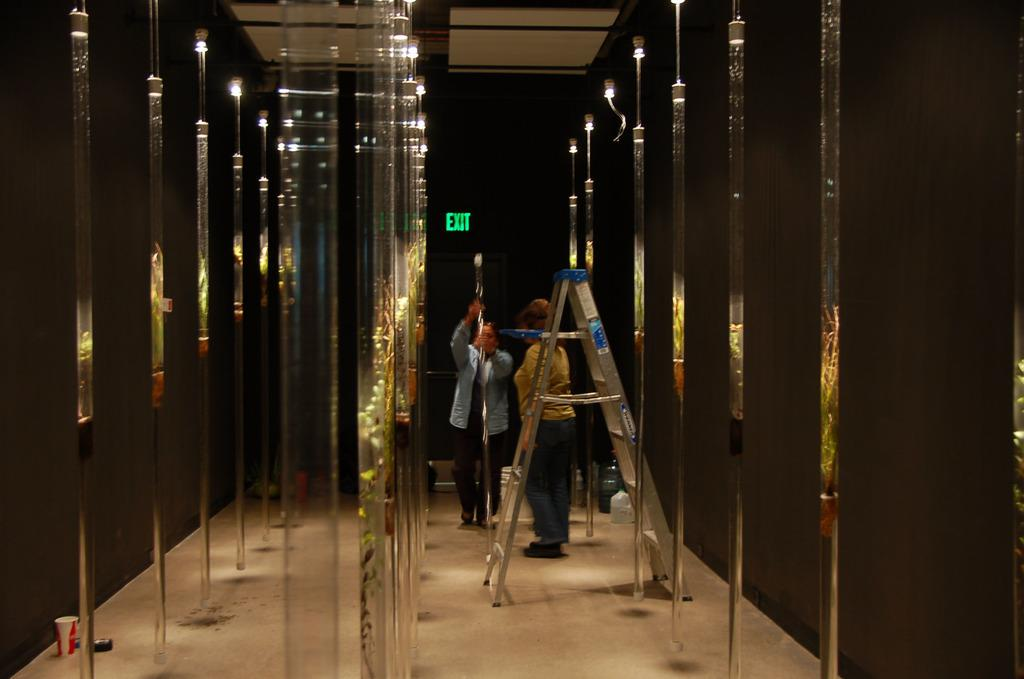<image>
Offer a succinct explanation of the picture presented. Two people standing behind a ladder with an exit sign behind them 